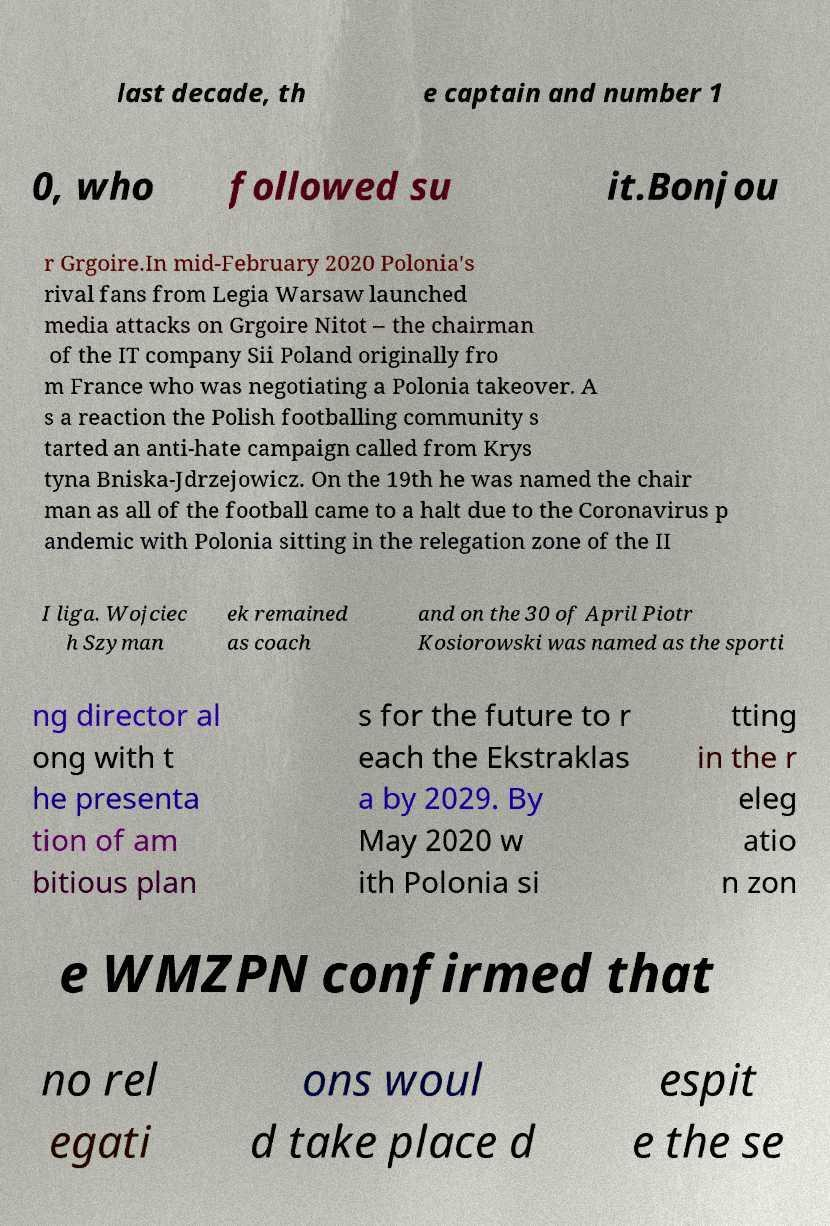What messages or text are displayed in this image? I need them in a readable, typed format. last decade, th e captain and number 1 0, who followed su it.Bonjou r Grgoire.In mid-February 2020 Polonia's rival fans from Legia Warsaw launched media attacks on Grgoire Nitot – the chairman of the IT company Sii Poland originally fro m France who was negotiating a Polonia takeover. A s a reaction the Polish footballing community s tarted an anti-hate campaign called from Krys tyna Bniska-Jdrzejowicz. On the 19th he was named the chair man as all of the football came to a halt due to the Coronavirus p andemic with Polonia sitting in the relegation zone of the II I liga. Wojciec h Szyman ek remained as coach and on the 30 of April Piotr Kosiorowski was named as the sporti ng director al ong with t he presenta tion of am bitious plan s for the future to r each the Ekstraklas a by 2029. By May 2020 w ith Polonia si tting in the r eleg atio n zon e WMZPN confirmed that no rel egati ons woul d take place d espit e the se 